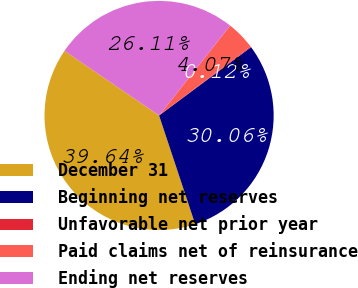Convert chart to OTSL. <chart><loc_0><loc_0><loc_500><loc_500><pie_chart><fcel>December 31<fcel>Beginning net reserves<fcel>Unfavorable net prior year<fcel>Paid claims net of reinsurance<fcel>Ending net reserves<nl><fcel>39.64%<fcel>30.06%<fcel>0.12%<fcel>4.07%<fcel>26.11%<nl></chart> 